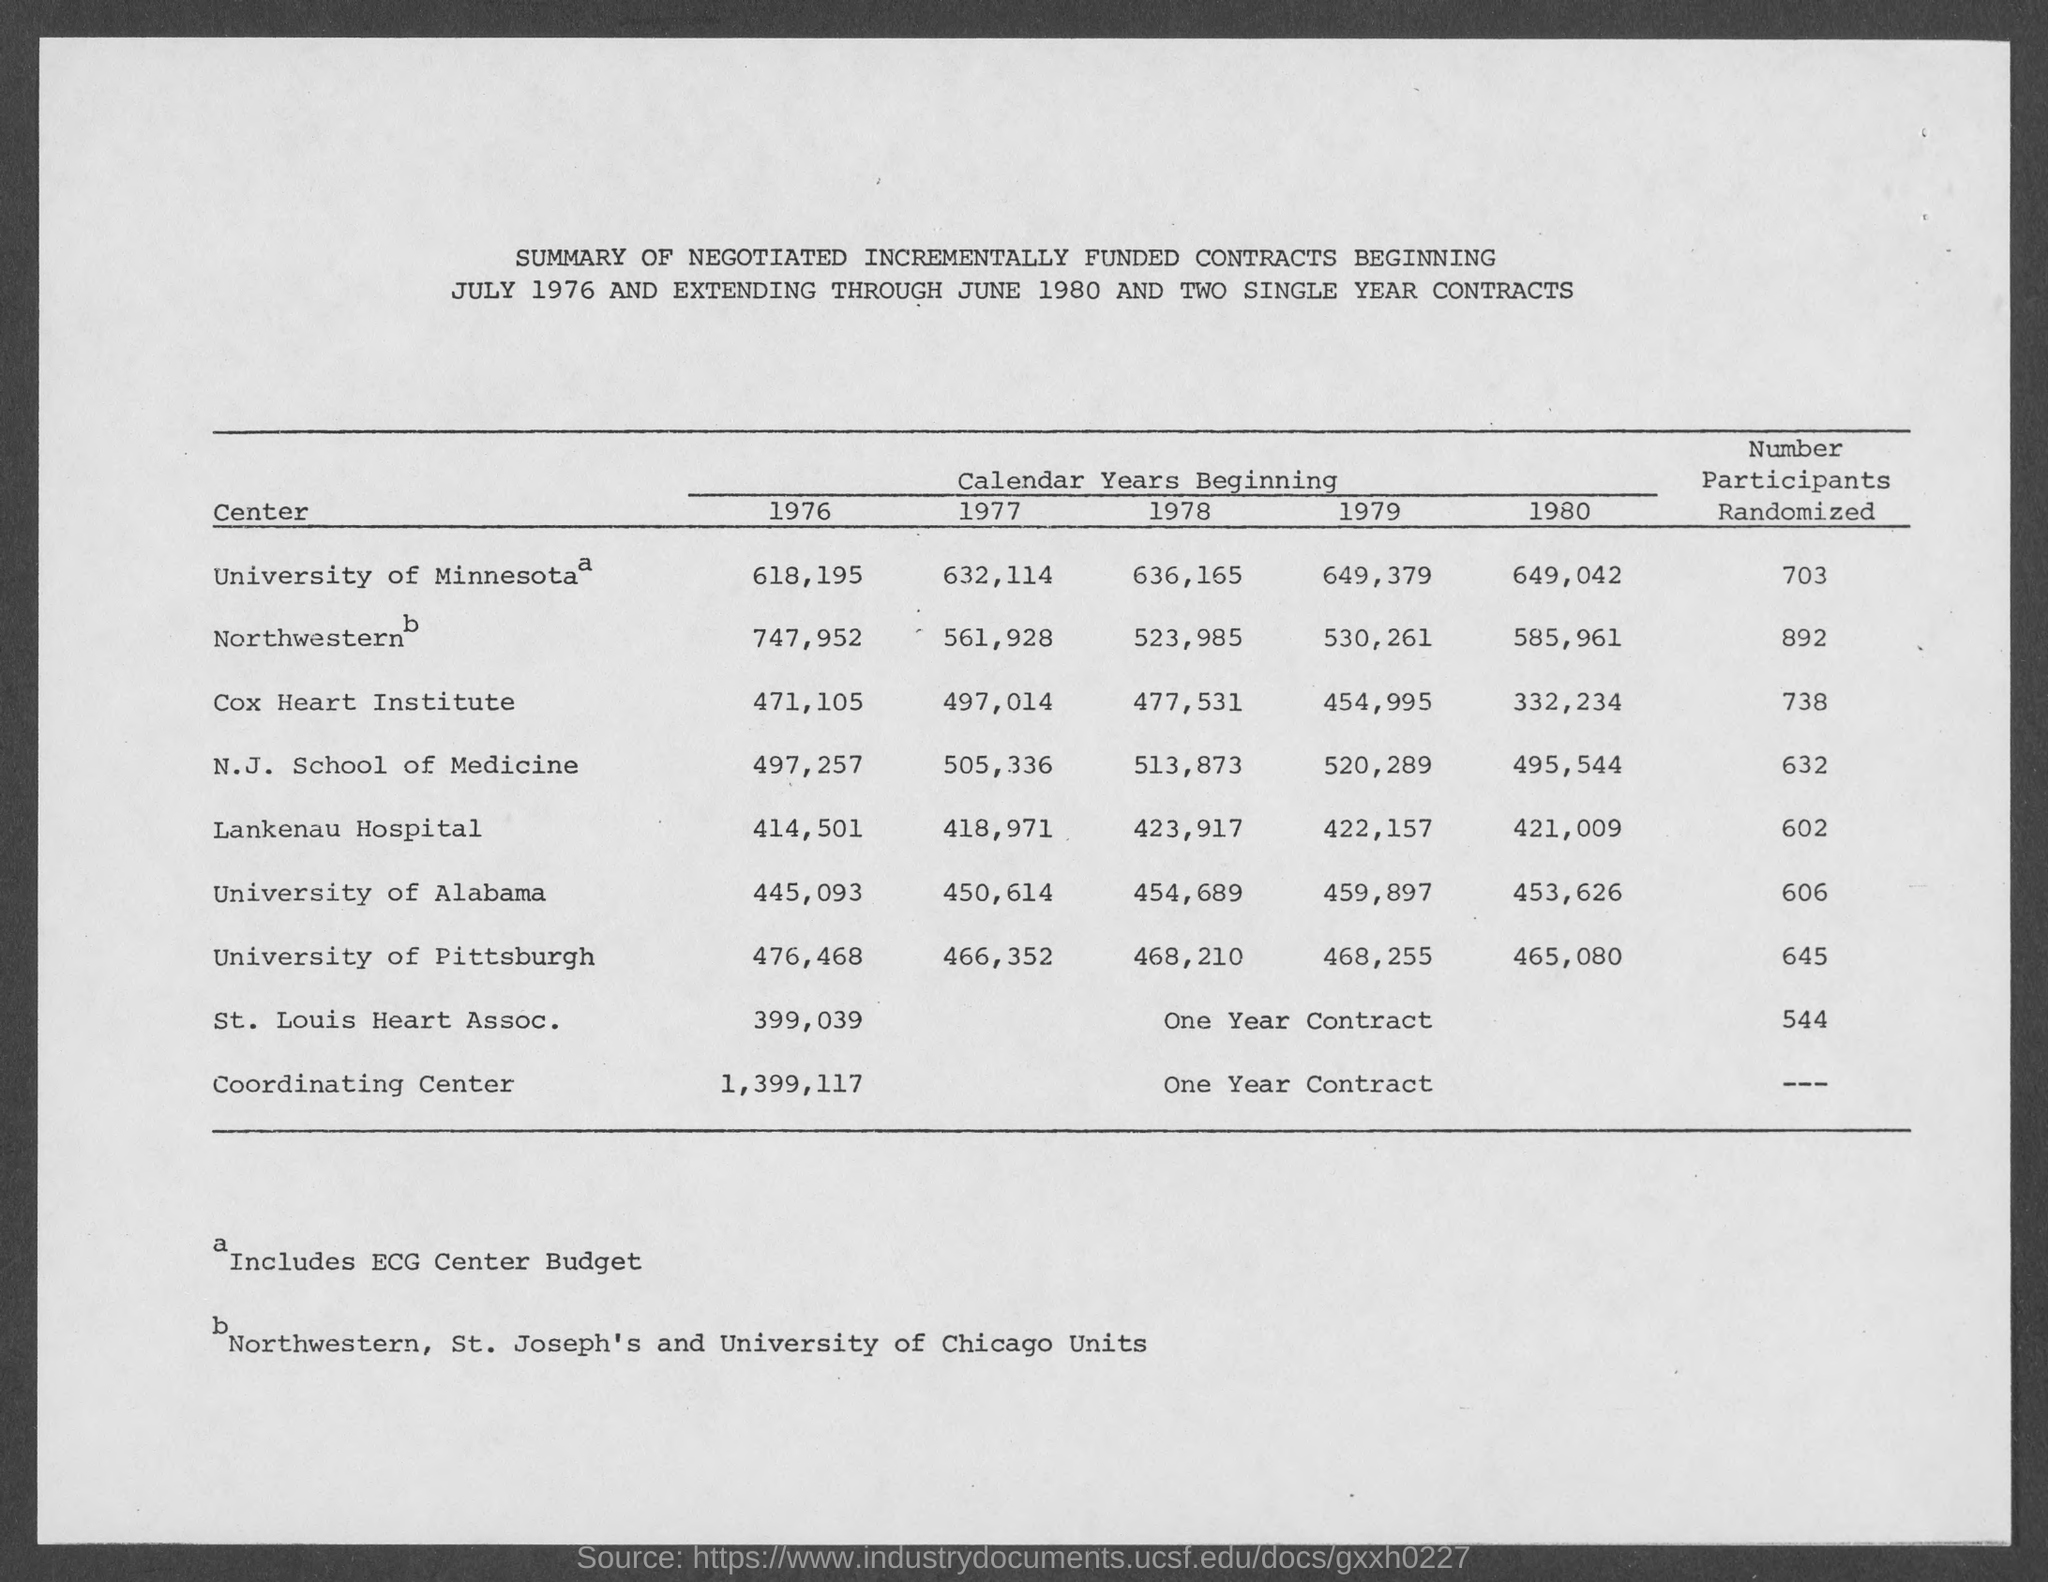What is the number of participants from the University of Minnesota?
Provide a short and direct response. 703. What is the number of participants from the University of Pittsburgh?
Make the answer very short. 645. What is the number of participants from the Cox Heart Institute?
Give a very brief answer. 738. 